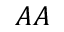<formula> <loc_0><loc_0><loc_500><loc_500>A A</formula> 